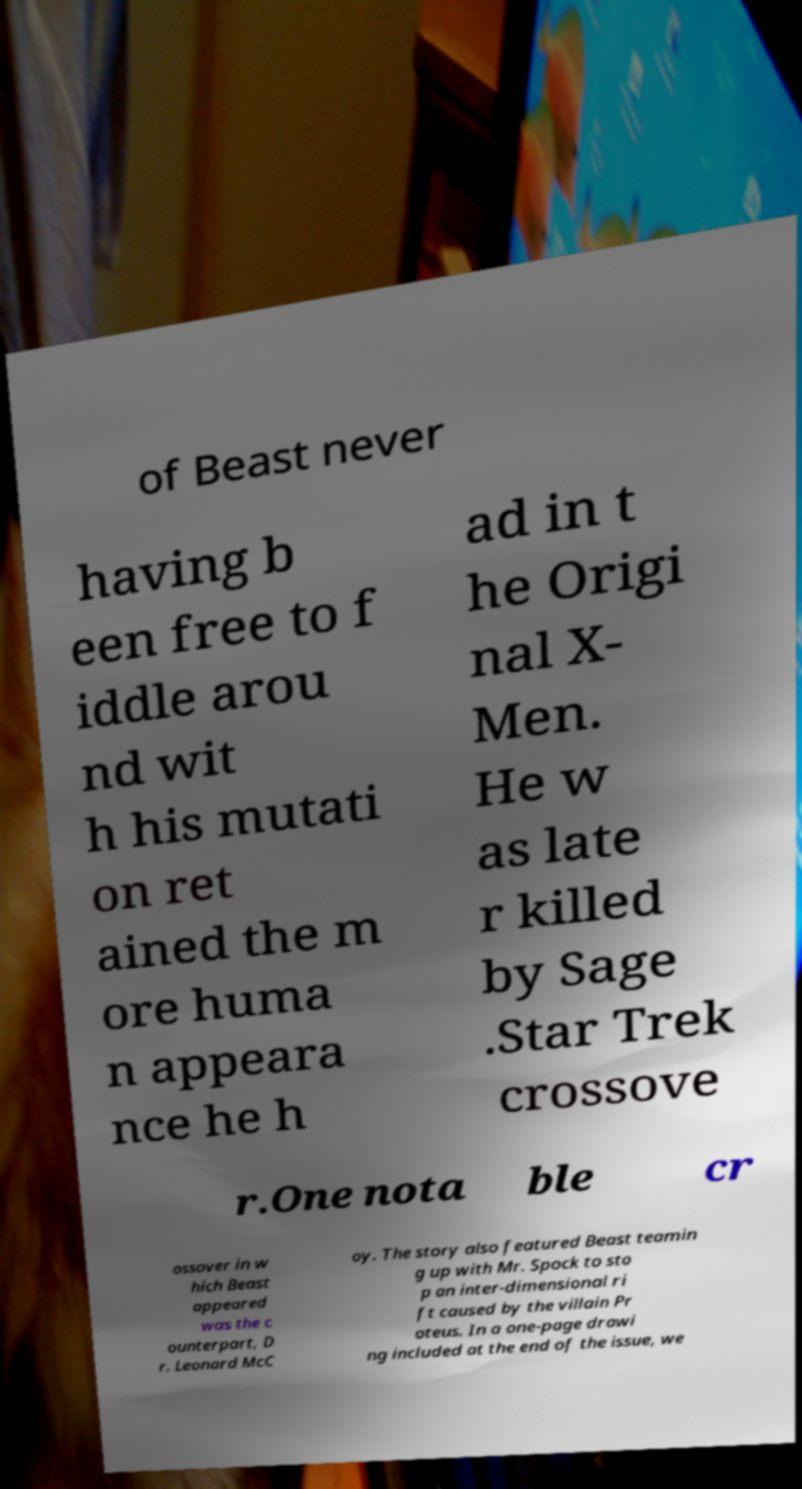Could you assist in decoding the text presented in this image and type it out clearly? of Beast never having b een free to f iddle arou nd wit h his mutati on ret ained the m ore huma n appeara nce he h ad in t he Origi nal X- Men. He w as late r killed by Sage .Star Trek crossove r.One nota ble cr ossover in w hich Beast appeared was the c ounterpart, D r. Leonard McC oy. The story also featured Beast teamin g up with Mr. Spock to sto p an inter-dimensional ri ft caused by the villain Pr oteus. In a one-page drawi ng included at the end of the issue, we 